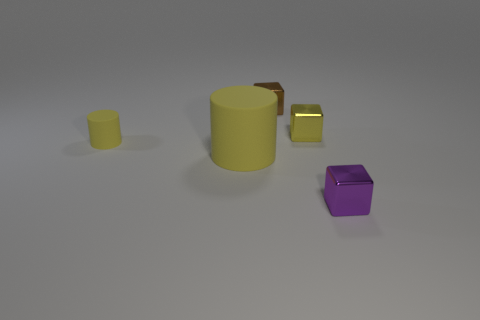How many tiny objects have the same color as the big cylinder?
Give a very brief answer. 2. There is a yellow block; does it have the same size as the cube on the left side of the yellow shiny object?
Give a very brief answer. Yes. Is there a rubber cylinder of the same size as the brown metal object?
Provide a short and direct response. Yes. What number of things are either tiny things or purple shiny objects?
Keep it short and to the point. 4. Do the yellow object to the right of the brown metal thing and the yellow cylinder to the left of the large yellow rubber object have the same size?
Give a very brief answer. Yes. Are there any small metallic things of the same shape as the big yellow thing?
Ensure brevity in your answer.  No. Are there fewer tiny yellow cubes that are to the right of the yellow metallic object than green rubber balls?
Make the answer very short. No. Do the tiny brown object and the tiny purple object have the same shape?
Give a very brief answer. Yes. What size is the cylinder to the left of the big yellow rubber thing?
Give a very brief answer. Small. What size is the thing that is made of the same material as the small cylinder?
Offer a terse response. Large. 